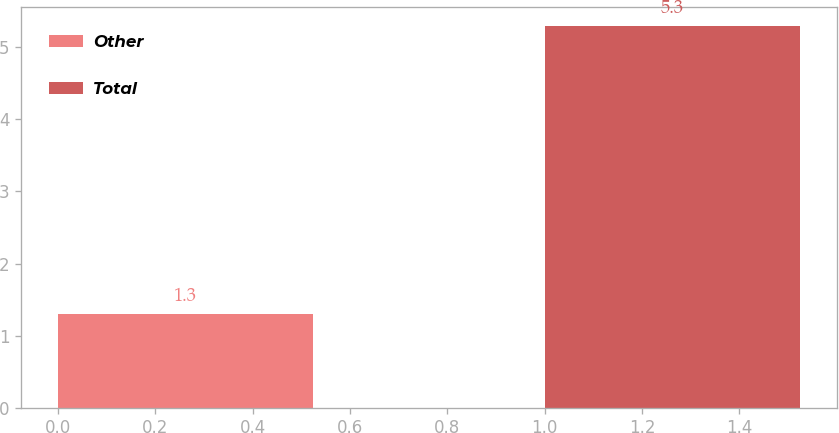<chart> <loc_0><loc_0><loc_500><loc_500><bar_chart><fcel>Other<fcel>Total<nl><fcel>1.3<fcel>5.3<nl></chart> 